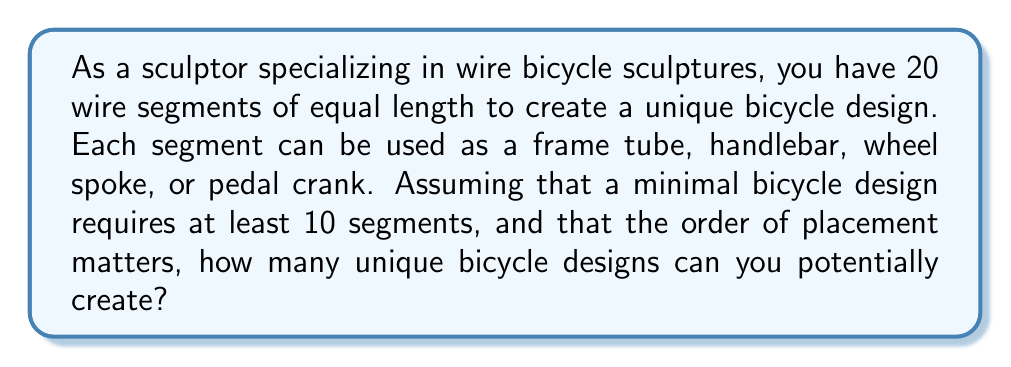Could you help me with this problem? Let's approach this step-by-step:

1) First, we need to consider that we can use anywhere from 10 to 20 segments for each design.

2) For each number of segments, we need to calculate the number of possible arrangements and then sum these up.

3) This is a problem of permutations with repetition, where the order matters (as specified in the question).

4) For each case (10 segments, 11 segments, etc.), we have 4 choices (frame tube, handlebar, wheel spoke, or pedal crank) for each segment.

5) The formula for permutations with repetition is:

   $$n^r$$

   where $n$ is the number of choices for each position, and $r$ is the number of positions.

6) So, for each case, we have:
   - 10 segments: $4^{10}$
   - 11 segments: $4^{11}$
   - ...
   - 20 segments: $4^{20}$

7) To get the total number of possible designs, we sum these up:

   $$\sum_{i=10}^{20} 4^i$$

8) This can be calculated as:

   $$4^{10} + 4^{11} + 4^{12} + ... + 4^{19} + 4^{20}$$

9) This is a geometric series with first term $a = 4^{10}$, common ratio $r = 4$, and 11 terms.

10) The sum of a geometric series is given by:

    $$S_n = \frac{a(1-r^n)}{1-r}$$

    where $a$ is the first term, $r$ is the common ratio, and $n$ is the number of terms.

11) Plugging in our values:

    $$S_{11} = \frac{4^{10}(1-4^{11})}{1-4} = \frac{4^{10}(4^{11}-1)}{3}$$

12) This evaluates to approximately $1.44 \times 10^{13}$
Answer: $\frac{4^{10}(4^{11}-1)}{3} \approx 1.44 \times 10^{13}$ unique designs 